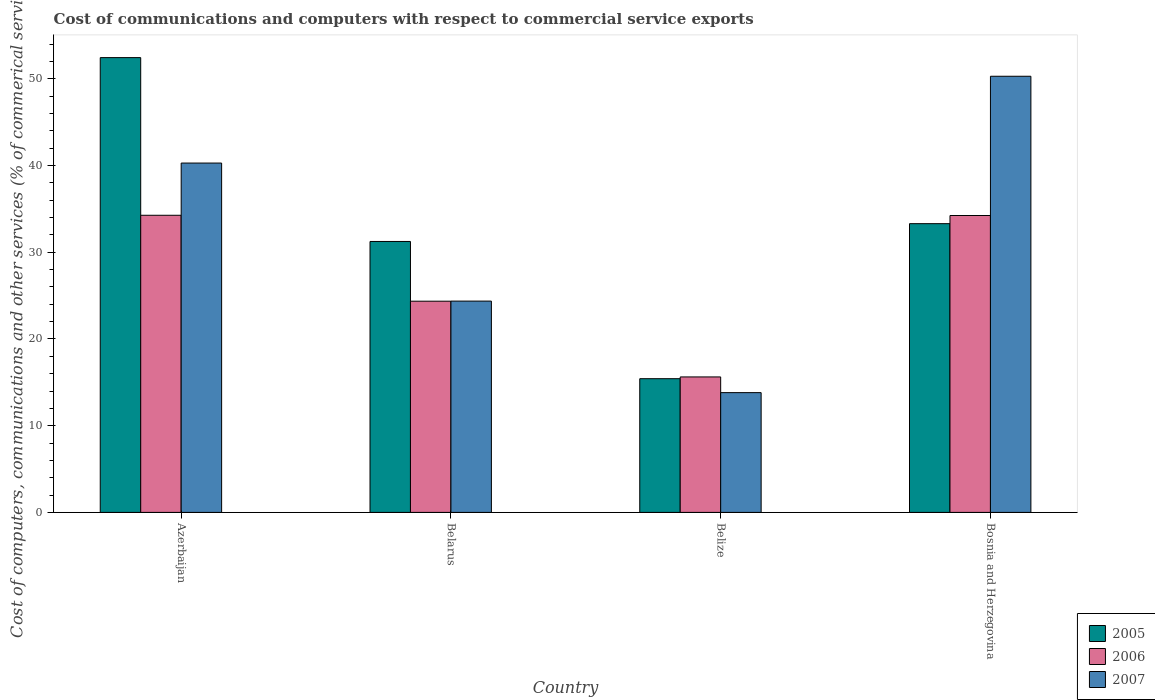How many different coloured bars are there?
Give a very brief answer. 3. Are the number of bars on each tick of the X-axis equal?
Ensure brevity in your answer.  Yes. How many bars are there on the 4th tick from the left?
Ensure brevity in your answer.  3. How many bars are there on the 4th tick from the right?
Keep it short and to the point. 3. What is the label of the 3rd group of bars from the left?
Ensure brevity in your answer.  Belize. What is the cost of communications and computers in 2007 in Azerbaijan?
Give a very brief answer. 40.29. Across all countries, what is the maximum cost of communications and computers in 2007?
Your answer should be very brief. 50.3. Across all countries, what is the minimum cost of communications and computers in 2006?
Offer a very short reply. 15.63. In which country was the cost of communications and computers in 2006 maximum?
Keep it short and to the point. Azerbaijan. In which country was the cost of communications and computers in 2006 minimum?
Provide a short and direct response. Belize. What is the total cost of communications and computers in 2005 in the graph?
Your answer should be very brief. 132.43. What is the difference between the cost of communications and computers in 2006 in Azerbaijan and that in Belize?
Offer a terse response. 18.64. What is the difference between the cost of communications and computers in 2006 in Belize and the cost of communications and computers in 2007 in Azerbaijan?
Your answer should be compact. -24.67. What is the average cost of communications and computers in 2006 per country?
Ensure brevity in your answer.  27.12. What is the difference between the cost of communications and computers of/in 2007 and cost of communications and computers of/in 2006 in Bosnia and Herzegovina?
Provide a succinct answer. 16.06. What is the ratio of the cost of communications and computers in 2006 in Belarus to that in Bosnia and Herzegovina?
Provide a short and direct response. 0.71. What is the difference between the highest and the second highest cost of communications and computers in 2007?
Keep it short and to the point. 15.92. What is the difference between the highest and the lowest cost of communications and computers in 2007?
Keep it short and to the point. 36.49. In how many countries, is the cost of communications and computers in 2005 greater than the average cost of communications and computers in 2005 taken over all countries?
Provide a short and direct response. 2. Is the sum of the cost of communications and computers in 2005 in Azerbaijan and Belarus greater than the maximum cost of communications and computers in 2007 across all countries?
Give a very brief answer. Yes. What does the 3rd bar from the left in Azerbaijan represents?
Make the answer very short. 2007. What does the 2nd bar from the right in Azerbaijan represents?
Your response must be concise. 2006. Is it the case that in every country, the sum of the cost of communications and computers in 2005 and cost of communications and computers in 2007 is greater than the cost of communications and computers in 2006?
Offer a terse response. Yes. How many bars are there?
Your answer should be compact. 12. Are all the bars in the graph horizontal?
Your response must be concise. No. Are the values on the major ticks of Y-axis written in scientific E-notation?
Give a very brief answer. No. Does the graph contain grids?
Give a very brief answer. No. Where does the legend appear in the graph?
Keep it short and to the point. Bottom right. How many legend labels are there?
Offer a terse response. 3. What is the title of the graph?
Provide a succinct answer. Cost of communications and computers with respect to commercial service exports. Does "1977" appear as one of the legend labels in the graph?
Your answer should be compact. No. What is the label or title of the Y-axis?
Keep it short and to the point. Cost of computers, communications and other services (% of commerical service exports). What is the Cost of computers, communications and other services (% of commerical service exports) in 2005 in Azerbaijan?
Your answer should be very brief. 52.45. What is the Cost of computers, communications and other services (% of commerical service exports) in 2006 in Azerbaijan?
Give a very brief answer. 34.27. What is the Cost of computers, communications and other services (% of commerical service exports) of 2007 in Azerbaijan?
Your response must be concise. 40.29. What is the Cost of computers, communications and other services (% of commerical service exports) of 2005 in Belarus?
Offer a very short reply. 31.25. What is the Cost of computers, communications and other services (% of commerical service exports) in 2006 in Belarus?
Your answer should be very brief. 24.36. What is the Cost of computers, communications and other services (% of commerical service exports) of 2007 in Belarus?
Your response must be concise. 24.37. What is the Cost of computers, communications and other services (% of commerical service exports) in 2005 in Belize?
Your response must be concise. 15.42. What is the Cost of computers, communications and other services (% of commerical service exports) of 2006 in Belize?
Provide a succinct answer. 15.63. What is the Cost of computers, communications and other services (% of commerical service exports) in 2007 in Belize?
Give a very brief answer. 13.81. What is the Cost of computers, communications and other services (% of commerical service exports) of 2005 in Bosnia and Herzegovina?
Offer a very short reply. 33.3. What is the Cost of computers, communications and other services (% of commerical service exports) in 2006 in Bosnia and Herzegovina?
Make the answer very short. 34.24. What is the Cost of computers, communications and other services (% of commerical service exports) in 2007 in Bosnia and Herzegovina?
Your response must be concise. 50.3. Across all countries, what is the maximum Cost of computers, communications and other services (% of commerical service exports) of 2005?
Provide a short and direct response. 52.45. Across all countries, what is the maximum Cost of computers, communications and other services (% of commerical service exports) in 2006?
Your answer should be compact. 34.27. Across all countries, what is the maximum Cost of computers, communications and other services (% of commerical service exports) of 2007?
Provide a succinct answer. 50.3. Across all countries, what is the minimum Cost of computers, communications and other services (% of commerical service exports) in 2005?
Make the answer very short. 15.42. Across all countries, what is the minimum Cost of computers, communications and other services (% of commerical service exports) of 2006?
Offer a terse response. 15.63. Across all countries, what is the minimum Cost of computers, communications and other services (% of commerical service exports) of 2007?
Your answer should be compact. 13.81. What is the total Cost of computers, communications and other services (% of commerical service exports) in 2005 in the graph?
Offer a terse response. 132.43. What is the total Cost of computers, communications and other services (% of commerical service exports) of 2006 in the graph?
Give a very brief answer. 108.5. What is the total Cost of computers, communications and other services (% of commerical service exports) in 2007 in the graph?
Offer a terse response. 128.78. What is the difference between the Cost of computers, communications and other services (% of commerical service exports) of 2005 in Azerbaijan and that in Belarus?
Make the answer very short. 21.2. What is the difference between the Cost of computers, communications and other services (% of commerical service exports) of 2006 in Azerbaijan and that in Belarus?
Keep it short and to the point. 9.91. What is the difference between the Cost of computers, communications and other services (% of commerical service exports) of 2007 in Azerbaijan and that in Belarus?
Your response must be concise. 15.92. What is the difference between the Cost of computers, communications and other services (% of commerical service exports) in 2005 in Azerbaijan and that in Belize?
Your answer should be compact. 37.03. What is the difference between the Cost of computers, communications and other services (% of commerical service exports) of 2006 in Azerbaijan and that in Belize?
Provide a succinct answer. 18.64. What is the difference between the Cost of computers, communications and other services (% of commerical service exports) of 2007 in Azerbaijan and that in Belize?
Keep it short and to the point. 26.48. What is the difference between the Cost of computers, communications and other services (% of commerical service exports) of 2005 in Azerbaijan and that in Bosnia and Herzegovina?
Your response must be concise. 19.15. What is the difference between the Cost of computers, communications and other services (% of commerical service exports) in 2006 in Azerbaijan and that in Bosnia and Herzegovina?
Give a very brief answer. 0.03. What is the difference between the Cost of computers, communications and other services (% of commerical service exports) of 2007 in Azerbaijan and that in Bosnia and Herzegovina?
Offer a terse response. -10.01. What is the difference between the Cost of computers, communications and other services (% of commerical service exports) in 2005 in Belarus and that in Belize?
Offer a very short reply. 15.83. What is the difference between the Cost of computers, communications and other services (% of commerical service exports) in 2006 in Belarus and that in Belize?
Provide a short and direct response. 8.73. What is the difference between the Cost of computers, communications and other services (% of commerical service exports) in 2007 in Belarus and that in Belize?
Your answer should be very brief. 10.56. What is the difference between the Cost of computers, communications and other services (% of commerical service exports) in 2005 in Belarus and that in Bosnia and Herzegovina?
Keep it short and to the point. -2.05. What is the difference between the Cost of computers, communications and other services (% of commerical service exports) in 2006 in Belarus and that in Bosnia and Herzegovina?
Your response must be concise. -9.88. What is the difference between the Cost of computers, communications and other services (% of commerical service exports) in 2007 in Belarus and that in Bosnia and Herzegovina?
Your answer should be very brief. -25.93. What is the difference between the Cost of computers, communications and other services (% of commerical service exports) in 2005 in Belize and that in Bosnia and Herzegovina?
Provide a succinct answer. -17.88. What is the difference between the Cost of computers, communications and other services (% of commerical service exports) in 2006 in Belize and that in Bosnia and Herzegovina?
Your response must be concise. -18.62. What is the difference between the Cost of computers, communications and other services (% of commerical service exports) of 2007 in Belize and that in Bosnia and Herzegovina?
Offer a terse response. -36.49. What is the difference between the Cost of computers, communications and other services (% of commerical service exports) in 2005 in Azerbaijan and the Cost of computers, communications and other services (% of commerical service exports) in 2006 in Belarus?
Your answer should be very brief. 28.1. What is the difference between the Cost of computers, communications and other services (% of commerical service exports) in 2005 in Azerbaijan and the Cost of computers, communications and other services (% of commerical service exports) in 2007 in Belarus?
Ensure brevity in your answer.  28.08. What is the difference between the Cost of computers, communications and other services (% of commerical service exports) of 2006 in Azerbaijan and the Cost of computers, communications and other services (% of commerical service exports) of 2007 in Belarus?
Give a very brief answer. 9.9. What is the difference between the Cost of computers, communications and other services (% of commerical service exports) in 2005 in Azerbaijan and the Cost of computers, communications and other services (% of commerical service exports) in 2006 in Belize?
Keep it short and to the point. 36.83. What is the difference between the Cost of computers, communications and other services (% of commerical service exports) in 2005 in Azerbaijan and the Cost of computers, communications and other services (% of commerical service exports) in 2007 in Belize?
Offer a very short reply. 38.64. What is the difference between the Cost of computers, communications and other services (% of commerical service exports) of 2006 in Azerbaijan and the Cost of computers, communications and other services (% of commerical service exports) of 2007 in Belize?
Provide a succinct answer. 20.46. What is the difference between the Cost of computers, communications and other services (% of commerical service exports) of 2005 in Azerbaijan and the Cost of computers, communications and other services (% of commerical service exports) of 2006 in Bosnia and Herzegovina?
Provide a short and direct response. 18.21. What is the difference between the Cost of computers, communications and other services (% of commerical service exports) in 2005 in Azerbaijan and the Cost of computers, communications and other services (% of commerical service exports) in 2007 in Bosnia and Herzegovina?
Give a very brief answer. 2.15. What is the difference between the Cost of computers, communications and other services (% of commerical service exports) in 2006 in Azerbaijan and the Cost of computers, communications and other services (% of commerical service exports) in 2007 in Bosnia and Herzegovina?
Provide a short and direct response. -16.04. What is the difference between the Cost of computers, communications and other services (% of commerical service exports) in 2005 in Belarus and the Cost of computers, communications and other services (% of commerical service exports) in 2006 in Belize?
Give a very brief answer. 15.62. What is the difference between the Cost of computers, communications and other services (% of commerical service exports) in 2005 in Belarus and the Cost of computers, communications and other services (% of commerical service exports) in 2007 in Belize?
Offer a terse response. 17.44. What is the difference between the Cost of computers, communications and other services (% of commerical service exports) in 2006 in Belarus and the Cost of computers, communications and other services (% of commerical service exports) in 2007 in Belize?
Offer a very short reply. 10.55. What is the difference between the Cost of computers, communications and other services (% of commerical service exports) in 2005 in Belarus and the Cost of computers, communications and other services (% of commerical service exports) in 2006 in Bosnia and Herzegovina?
Offer a terse response. -2.99. What is the difference between the Cost of computers, communications and other services (% of commerical service exports) of 2005 in Belarus and the Cost of computers, communications and other services (% of commerical service exports) of 2007 in Bosnia and Herzegovina?
Your answer should be very brief. -19.05. What is the difference between the Cost of computers, communications and other services (% of commerical service exports) of 2006 in Belarus and the Cost of computers, communications and other services (% of commerical service exports) of 2007 in Bosnia and Herzegovina?
Provide a short and direct response. -25.95. What is the difference between the Cost of computers, communications and other services (% of commerical service exports) of 2005 in Belize and the Cost of computers, communications and other services (% of commerical service exports) of 2006 in Bosnia and Herzegovina?
Offer a very short reply. -18.82. What is the difference between the Cost of computers, communications and other services (% of commerical service exports) in 2005 in Belize and the Cost of computers, communications and other services (% of commerical service exports) in 2007 in Bosnia and Herzegovina?
Provide a short and direct response. -34.88. What is the difference between the Cost of computers, communications and other services (% of commerical service exports) in 2006 in Belize and the Cost of computers, communications and other services (% of commerical service exports) in 2007 in Bosnia and Herzegovina?
Ensure brevity in your answer.  -34.68. What is the average Cost of computers, communications and other services (% of commerical service exports) of 2005 per country?
Offer a terse response. 33.11. What is the average Cost of computers, communications and other services (% of commerical service exports) in 2006 per country?
Provide a succinct answer. 27.12. What is the average Cost of computers, communications and other services (% of commerical service exports) in 2007 per country?
Keep it short and to the point. 32.2. What is the difference between the Cost of computers, communications and other services (% of commerical service exports) of 2005 and Cost of computers, communications and other services (% of commerical service exports) of 2006 in Azerbaijan?
Offer a very short reply. 18.19. What is the difference between the Cost of computers, communications and other services (% of commerical service exports) of 2005 and Cost of computers, communications and other services (% of commerical service exports) of 2007 in Azerbaijan?
Offer a terse response. 12.16. What is the difference between the Cost of computers, communications and other services (% of commerical service exports) in 2006 and Cost of computers, communications and other services (% of commerical service exports) in 2007 in Azerbaijan?
Give a very brief answer. -6.02. What is the difference between the Cost of computers, communications and other services (% of commerical service exports) of 2005 and Cost of computers, communications and other services (% of commerical service exports) of 2006 in Belarus?
Provide a short and direct response. 6.89. What is the difference between the Cost of computers, communications and other services (% of commerical service exports) in 2005 and Cost of computers, communications and other services (% of commerical service exports) in 2007 in Belarus?
Give a very brief answer. 6.88. What is the difference between the Cost of computers, communications and other services (% of commerical service exports) of 2006 and Cost of computers, communications and other services (% of commerical service exports) of 2007 in Belarus?
Provide a succinct answer. -0.01. What is the difference between the Cost of computers, communications and other services (% of commerical service exports) of 2005 and Cost of computers, communications and other services (% of commerical service exports) of 2006 in Belize?
Offer a terse response. -0.2. What is the difference between the Cost of computers, communications and other services (% of commerical service exports) in 2005 and Cost of computers, communications and other services (% of commerical service exports) in 2007 in Belize?
Your response must be concise. 1.61. What is the difference between the Cost of computers, communications and other services (% of commerical service exports) in 2006 and Cost of computers, communications and other services (% of commerical service exports) in 2007 in Belize?
Provide a short and direct response. 1.81. What is the difference between the Cost of computers, communications and other services (% of commerical service exports) of 2005 and Cost of computers, communications and other services (% of commerical service exports) of 2006 in Bosnia and Herzegovina?
Your answer should be very brief. -0.94. What is the difference between the Cost of computers, communications and other services (% of commerical service exports) of 2005 and Cost of computers, communications and other services (% of commerical service exports) of 2007 in Bosnia and Herzegovina?
Your answer should be very brief. -17. What is the difference between the Cost of computers, communications and other services (% of commerical service exports) in 2006 and Cost of computers, communications and other services (% of commerical service exports) in 2007 in Bosnia and Herzegovina?
Give a very brief answer. -16.06. What is the ratio of the Cost of computers, communications and other services (% of commerical service exports) of 2005 in Azerbaijan to that in Belarus?
Make the answer very short. 1.68. What is the ratio of the Cost of computers, communications and other services (% of commerical service exports) in 2006 in Azerbaijan to that in Belarus?
Make the answer very short. 1.41. What is the ratio of the Cost of computers, communications and other services (% of commerical service exports) of 2007 in Azerbaijan to that in Belarus?
Offer a terse response. 1.65. What is the ratio of the Cost of computers, communications and other services (% of commerical service exports) in 2005 in Azerbaijan to that in Belize?
Provide a short and direct response. 3.4. What is the ratio of the Cost of computers, communications and other services (% of commerical service exports) of 2006 in Azerbaijan to that in Belize?
Offer a very short reply. 2.19. What is the ratio of the Cost of computers, communications and other services (% of commerical service exports) in 2007 in Azerbaijan to that in Belize?
Offer a terse response. 2.92. What is the ratio of the Cost of computers, communications and other services (% of commerical service exports) of 2005 in Azerbaijan to that in Bosnia and Herzegovina?
Keep it short and to the point. 1.58. What is the ratio of the Cost of computers, communications and other services (% of commerical service exports) of 2007 in Azerbaijan to that in Bosnia and Herzegovina?
Give a very brief answer. 0.8. What is the ratio of the Cost of computers, communications and other services (% of commerical service exports) of 2005 in Belarus to that in Belize?
Provide a succinct answer. 2.03. What is the ratio of the Cost of computers, communications and other services (% of commerical service exports) in 2006 in Belarus to that in Belize?
Provide a short and direct response. 1.56. What is the ratio of the Cost of computers, communications and other services (% of commerical service exports) of 2007 in Belarus to that in Belize?
Provide a succinct answer. 1.76. What is the ratio of the Cost of computers, communications and other services (% of commerical service exports) of 2005 in Belarus to that in Bosnia and Herzegovina?
Your response must be concise. 0.94. What is the ratio of the Cost of computers, communications and other services (% of commerical service exports) of 2006 in Belarus to that in Bosnia and Herzegovina?
Your answer should be very brief. 0.71. What is the ratio of the Cost of computers, communications and other services (% of commerical service exports) of 2007 in Belarus to that in Bosnia and Herzegovina?
Keep it short and to the point. 0.48. What is the ratio of the Cost of computers, communications and other services (% of commerical service exports) in 2005 in Belize to that in Bosnia and Herzegovina?
Your answer should be very brief. 0.46. What is the ratio of the Cost of computers, communications and other services (% of commerical service exports) of 2006 in Belize to that in Bosnia and Herzegovina?
Ensure brevity in your answer.  0.46. What is the ratio of the Cost of computers, communications and other services (% of commerical service exports) in 2007 in Belize to that in Bosnia and Herzegovina?
Your answer should be compact. 0.27. What is the difference between the highest and the second highest Cost of computers, communications and other services (% of commerical service exports) in 2005?
Keep it short and to the point. 19.15. What is the difference between the highest and the second highest Cost of computers, communications and other services (% of commerical service exports) in 2006?
Your answer should be very brief. 0.03. What is the difference between the highest and the second highest Cost of computers, communications and other services (% of commerical service exports) of 2007?
Offer a terse response. 10.01. What is the difference between the highest and the lowest Cost of computers, communications and other services (% of commerical service exports) in 2005?
Provide a short and direct response. 37.03. What is the difference between the highest and the lowest Cost of computers, communications and other services (% of commerical service exports) of 2006?
Keep it short and to the point. 18.64. What is the difference between the highest and the lowest Cost of computers, communications and other services (% of commerical service exports) of 2007?
Offer a terse response. 36.49. 